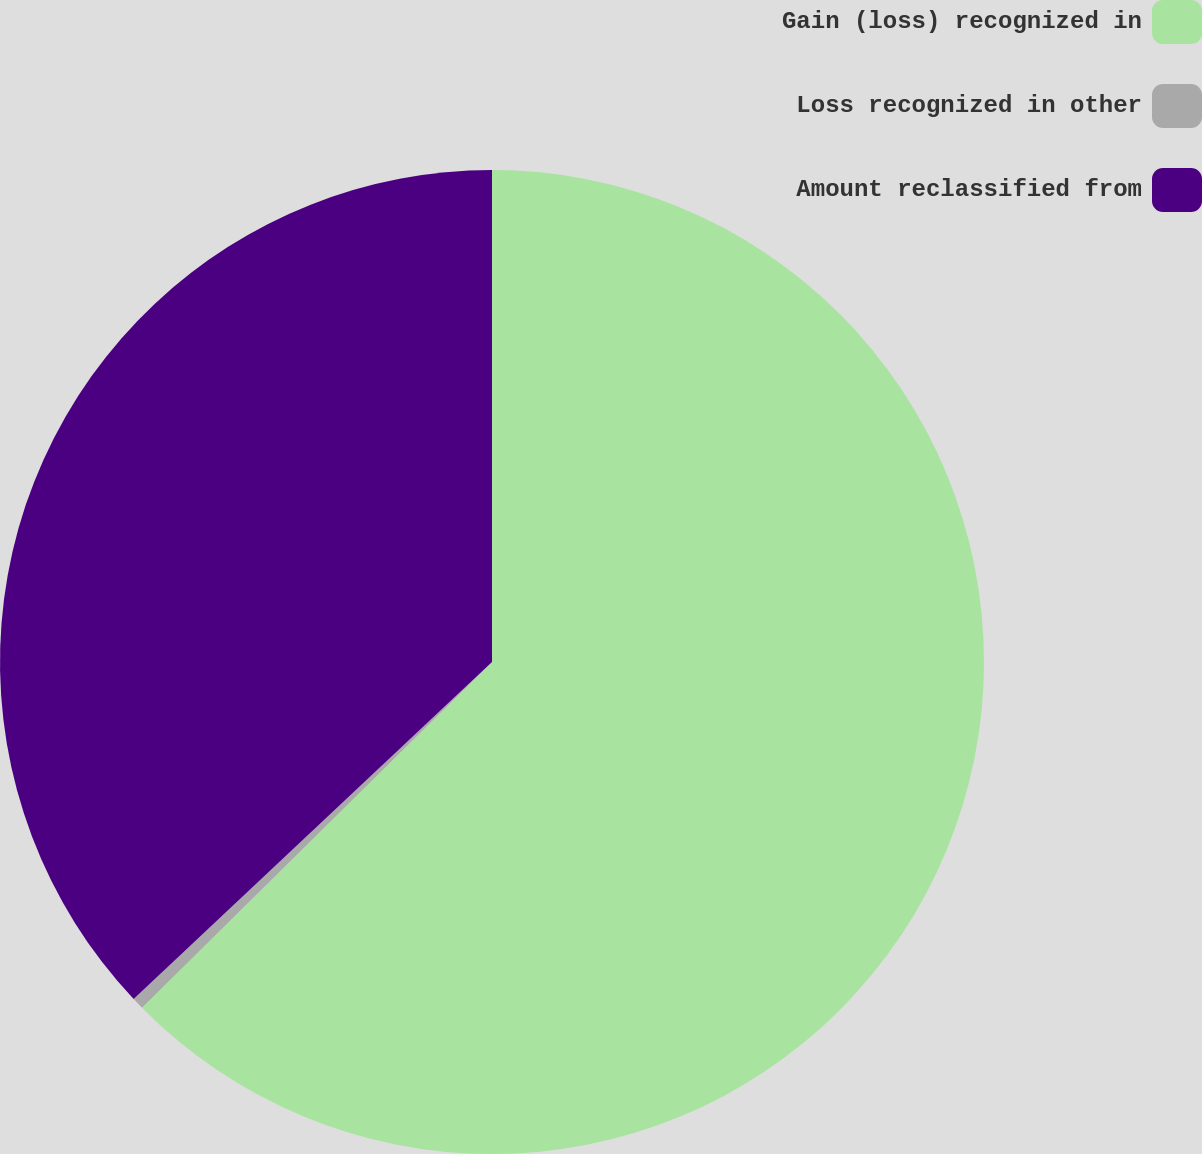Convert chart to OTSL. <chart><loc_0><loc_0><loc_500><loc_500><pie_chart><fcel>Gain (loss) recognized in<fcel>Loss recognized in other<fcel>Amount reclassified from<nl><fcel>62.59%<fcel>0.39%<fcel>37.01%<nl></chart> 